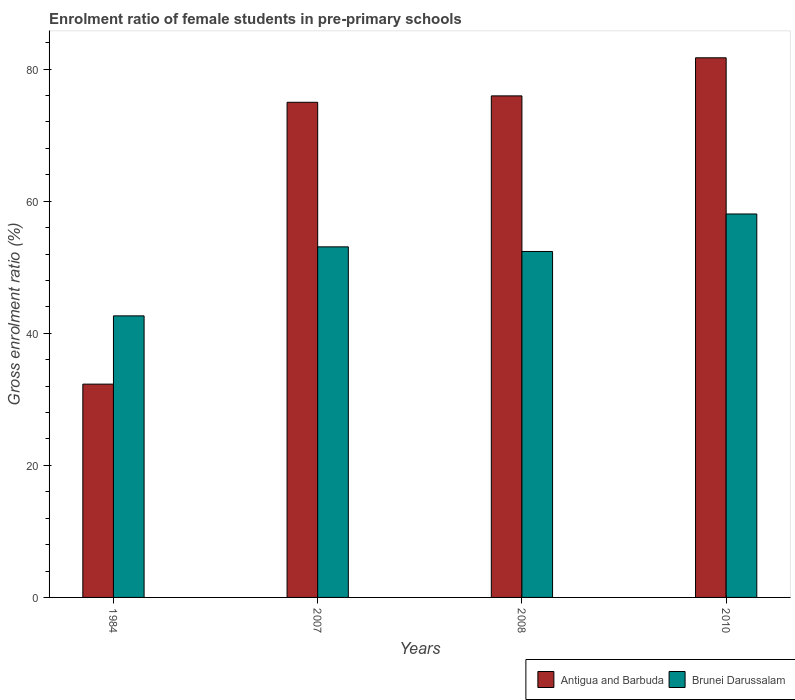Are the number of bars per tick equal to the number of legend labels?
Provide a short and direct response. Yes. How many bars are there on the 1st tick from the left?
Make the answer very short. 2. What is the enrolment ratio of female students in pre-primary schools in Brunei Darussalam in 2008?
Make the answer very short. 52.39. Across all years, what is the maximum enrolment ratio of female students in pre-primary schools in Antigua and Barbuda?
Provide a short and direct response. 81.72. Across all years, what is the minimum enrolment ratio of female students in pre-primary schools in Antigua and Barbuda?
Make the answer very short. 32.3. In which year was the enrolment ratio of female students in pre-primary schools in Antigua and Barbuda maximum?
Make the answer very short. 2010. In which year was the enrolment ratio of female students in pre-primary schools in Antigua and Barbuda minimum?
Offer a very short reply. 1984. What is the total enrolment ratio of female students in pre-primary schools in Antigua and Barbuda in the graph?
Make the answer very short. 264.96. What is the difference between the enrolment ratio of female students in pre-primary schools in Brunei Darussalam in 1984 and that in 2008?
Give a very brief answer. -9.75. What is the difference between the enrolment ratio of female students in pre-primary schools in Antigua and Barbuda in 2007 and the enrolment ratio of female students in pre-primary schools in Brunei Darussalam in 2010?
Provide a short and direct response. 16.91. What is the average enrolment ratio of female students in pre-primary schools in Antigua and Barbuda per year?
Your answer should be compact. 66.24. In the year 2007, what is the difference between the enrolment ratio of female students in pre-primary schools in Antigua and Barbuda and enrolment ratio of female students in pre-primary schools in Brunei Darussalam?
Give a very brief answer. 21.89. In how many years, is the enrolment ratio of female students in pre-primary schools in Antigua and Barbuda greater than 52 %?
Make the answer very short. 3. What is the ratio of the enrolment ratio of female students in pre-primary schools in Antigua and Barbuda in 2007 to that in 2010?
Your answer should be very brief. 0.92. What is the difference between the highest and the second highest enrolment ratio of female students in pre-primary schools in Antigua and Barbuda?
Your response must be concise. 5.77. What is the difference between the highest and the lowest enrolment ratio of female students in pre-primary schools in Antigua and Barbuda?
Provide a short and direct response. 49.42. What does the 2nd bar from the left in 2010 represents?
Give a very brief answer. Brunei Darussalam. What does the 1st bar from the right in 2010 represents?
Provide a short and direct response. Brunei Darussalam. How many bars are there?
Give a very brief answer. 8. What is the difference between two consecutive major ticks on the Y-axis?
Your response must be concise. 20. Are the values on the major ticks of Y-axis written in scientific E-notation?
Your response must be concise. No. Does the graph contain any zero values?
Keep it short and to the point. No. Where does the legend appear in the graph?
Keep it short and to the point. Bottom right. How many legend labels are there?
Provide a succinct answer. 2. What is the title of the graph?
Your response must be concise. Enrolment ratio of female students in pre-primary schools. What is the Gross enrolment ratio (%) of Antigua and Barbuda in 1984?
Keep it short and to the point. 32.3. What is the Gross enrolment ratio (%) of Brunei Darussalam in 1984?
Provide a succinct answer. 42.64. What is the Gross enrolment ratio (%) in Antigua and Barbuda in 2007?
Make the answer very short. 74.98. What is the Gross enrolment ratio (%) in Brunei Darussalam in 2007?
Make the answer very short. 53.09. What is the Gross enrolment ratio (%) of Antigua and Barbuda in 2008?
Your answer should be compact. 75.96. What is the Gross enrolment ratio (%) in Brunei Darussalam in 2008?
Offer a very short reply. 52.39. What is the Gross enrolment ratio (%) of Antigua and Barbuda in 2010?
Ensure brevity in your answer.  81.72. What is the Gross enrolment ratio (%) in Brunei Darussalam in 2010?
Make the answer very short. 58.07. Across all years, what is the maximum Gross enrolment ratio (%) of Antigua and Barbuda?
Your answer should be compact. 81.72. Across all years, what is the maximum Gross enrolment ratio (%) in Brunei Darussalam?
Make the answer very short. 58.07. Across all years, what is the minimum Gross enrolment ratio (%) of Antigua and Barbuda?
Provide a succinct answer. 32.3. Across all years, what is the minimum Gross enrolment ratio (%) of Brunei Darussalam?
Give a very brief answer. 42.64. What is the total Gross enrolment ratio (%) of Antigua and Barbuda in the graph?
Your answer should be very brief. 264.96. What is the total Gross enrolment ratio (%) of Brunei Darussalam in the graph?
Your answer should be very brief. 206.19. What is the difference between the Gross enrolment ratio (%) of Antigua and Barbuda in 1984 and that in 2007?
Your response must be concise. -42.68. What is the difference between the Gross enrolment ratio (%) of Brunei Darussalam in 1984 and that in 2007?
Give a very brief answer. -10.45. What is the difference between the Gross enrolment ratio (%) in Antigua and Barbuda in 1984 and that in 2008?
Give a very brief answer. -43.65. What is the difference between the Gross enrolment ratio (%) of Brunei Darussalam in 1984 and that in 2008?
Your answer should be compact. -9.75. What is the difference between the Gross enrolment ratio (%) of Antigua and Barbuda in 1984 and that in 2010?
Make the answer very short. -49.42. What is the difference between the Gross enrolment ratio (%) of Brunei Darussalam in 1984 and that in 2010?
Your answer should be very brief. -15.43. What is the difference between the Gross enrolment ratio (%) of Antigua and Barbuda in 2007 and that in 2008?
Provide a short and direct response. -0.97. What is the difference between the Gross enrolment ratio (%) in Brunei Darussalam in 2007 and that in 2008?
Your answer should be very brief. 0.7. What is the difference between the Gross enrolment ratio (%) of Antigua and Barbuda in 2007 and that in 2010?
Keep it short and to the point. -6.74. What is the difference between the Gross enrolment ratio (%) of Brunei Darussalam in 2007 and that in 2010?
Keep it short and to the point. -4.98. What is the difference between the Gross enrolment ratio (%) of Antigua and Barbuda in 2008 and that in 2010?
Provide a succinct answer. -5.77. What is the difference between the Gross enrolment ratio (%) in Brunei Darussalam in 2008 and that in 2010?
Give a very brief answer. -5.68. What is the difference between the Gross enrolment ratio (%) of Antigua and Barbuda in 1984 and the Gross enrolment ratio (%) of Brunei Darussalam in 2007?
Offer a very short reply. -20.79. What is the difference between the Gross enrolment ratio (%) of Antigua and Barbuda in 1984 and the Gross enrolment ratio (%) of Brunei Darussalam in 2008?
Make the answer very short. -20.09. What is the difference between the Gross enrolment ratio (%) in Antigua and Barbuda in 1984 and the Gross enrolment ratio (%) in Brunei Darussalam in 2010?
Your answer should be compact. -25.77. What is the difference between the Gross enrolment ratio (%) in Antigua and Barbuda in 2007 and the Gross enrolment ratio (%) in Brunei Darussalam in 2008?
Offer a very short reply. 22.59. What is the difference between the Gross enrolment ratio (%) of Antigua and Barbuda in 2007 and the Gross enrolment ratio (%) of Brunei Darussalam in 2010?
Make the answer very short. 16.91. What is the difference between the Gross enrolment ratio (%) of Antigua and Barbuda in 2008 and the Gross enrolment ratio (%) of Brunei Darussalam in 2010?
Provide a succinct answer. 17.88. What is the average Gross enrolment ratio (%) in Antigua and Barbuda per year?
Ensure brevity in your answer.  66.24. What is the average Gross enrolment ratio (%) in Brunei Darussalam per year?
Give a very brief answer. 51.55. In the year 1984, what is the difference between the Gross enrolment ratio (%) in Antigua and Barbuda and Gross enrolment ratio (%) in Brunei Darussalam?
Give a very brief answer. -10.34. In the year 2007, what is the difference between the Gross enrolment ratio (%) in Antigua and Barbuda and Gross enrolment ratio (%) in Brunei Darussalam?
Your answer should be very brief. 21.89. In the year 2008, what is the difference between the Gross enrolment ratio (%) of Antigua and Barbuda and Gross enrolment ratio (%) of Brunei Darussalam?
Offer a very short reply. 23.56. In the year 2010, what is the difference between the Gross enrolment ratio (%) in Antigua and Barbuda and Gross enrolment ratio (%) in Brunei Darussalam?
Keep it short and to the point. 23.65. What is the ratio of the Gross enrolment ratio (%) of Antigua and Barbuda in 1984 to that in 2007?
Provide a succinct answer. 0.43. What is the ratio of the Gross enrolment ratio (%) of Brunei Darussalam in 1984 to that in 2007?
Provide a short and direct response. 0.8. What is the ratio of the Gross enrolment ratio (%) of Antigua and Barbuda in 1984 to that in 2008?
Ensure brevity in your answer.  0.43. What is the ratio of the Gross enrolment ratio (%) in Brunei Darussalam in 1984 to that in 2008?
Offer a very short reply. 0.81. What is the ratio of the Gross enrolment ratio (%) of Antigua and Barbuda in 1984 to that in 2010?
Keep it short and to the point. 0.4. What is the ratio of the Gross enrolment ratio (%) in Brunei Darussalam in 1984 to that in 2010?
Your answer should be very brief. 0.73. What is the ratio of the Gross enrolment ratio (%) in Antigua and Barbuda in 2007 to that in 2008?
Your answer should be very brief. 0.99. What is the ratio of the Gross enrolment ratio (%) in Brunei Darussalam in 2007 to that in 2008?
Make the answer very short. 1.01. What is the ratio of the Gross enrolment ratio (%) in Antigua and Barbuda in 2007 to that in 2010?
Provide a succinct answer. 0.92. What is the ratio of the Gross enrolment ratio (%) in Brunei Darussalam in 2007 to that in 2010?
Make the answer very short. 0.91. What is the ratio of the Gross enrolment ratio (%) in Antigua and Barbuda in 2008 to that in 2010?
Make the answer very short. 0.93. What is the ratio of the Gross enrolment ratio (%) in Brunei Darussalam in 2008 to that in 2010?
Make the answer very short. 0.9. What is the difference between the highest and the second highest Gross enrolment ratio (%) of Antigua and Barbuda?
Ensure brevity in your answer.  5.77. What is the difference between the highest and the second highest Gross enrolment ratio (%) of Brunei Darussalam?
Provide a short and direct response. 4.98. What is the difference between the highest and the lowest Gross enrolment ratio (%) of Antigua and Barbuda?
Offer a terse response. 49.42. What is the difference between the highest and the lowest Gross enrolment ratio (%) of Brunei Darussalam?
Offer a terse response. 15.43. 